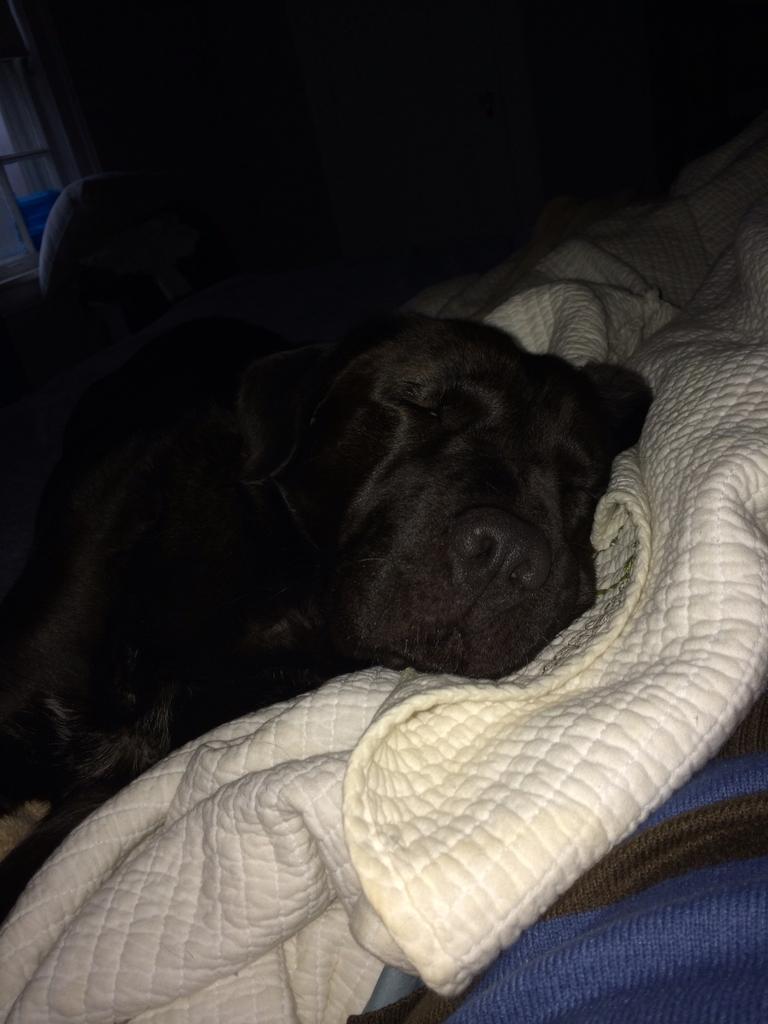In one or two sentences, can you explain what this image depicts? In this image we can see a dog is sleeping on the white blanket. There is a blue color object at bottom of the image. 